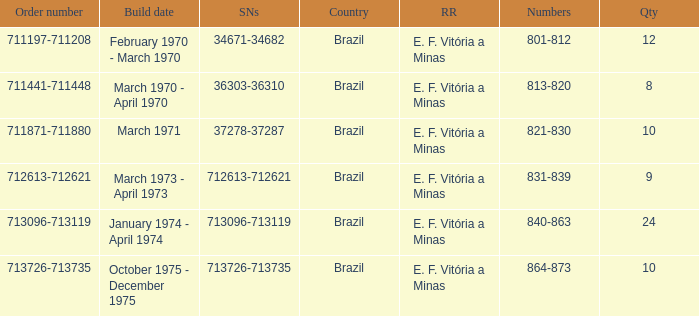The order number 713726-713735 has what serial number? 713726-713735. 